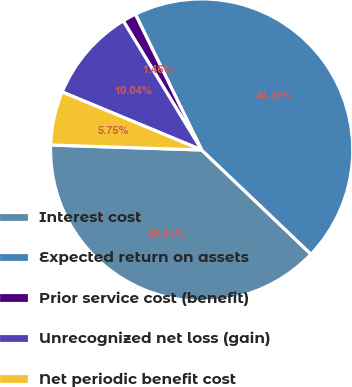<chart> <loc_0><loc_0><loc_500><loc_500><pie_chart><fcel>Interest cost<fcel>Expected return on assets<fcel>Prior service cost (benefit)<fcel>Unrecognized net loss (gain)<fcel>Net periodic benefit cost<nl><fcel>38.41%<fcel>44.35%<fcel>1.46%<fcel>10.04%<fcel>5.75%<nl></chart> 